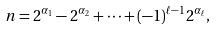Convert formula to latex. <formula><loc_0><loc_0><loc_500><loc_500>n = 2 ^ { \alpha _ { 1 } } - 2 ^ { \alpha _ { 2 } } + \cdots + ( - 1 ) ^ { \ell - 1 } 2 ^ { \alpha _ { \ell } } ,</formula> 